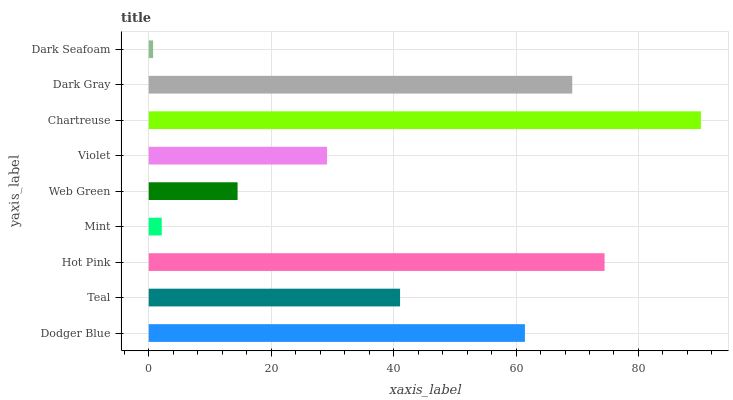Is Dark Seafoam the minimum?
Answer yes or no. Yes. Is Chartreuse the maximum?
Answer yes or no. Yes. Is Teal the minimum?
Answer yes or no. No. Is Teal the maximum?
Answer yes or no. No. Is Dodger Blue greater than Teal?
Answer yes or no. Yes. Is Teal less than Dodger Blue?
Answer yes or no. Yes. Is Teal greater than Dodger Blue?
Answer yes or no. No. Is Dodger Blue less than Teal?
Answer yes or no. No. Is Teal the high median?
Answer yes or no. Yes. Is Teal the low median?
Answer yes or no. Yes. Is Dark Gray the high median?
Answer yes or no. No. Is Web Green the low median?
Answer yes or no. No. 